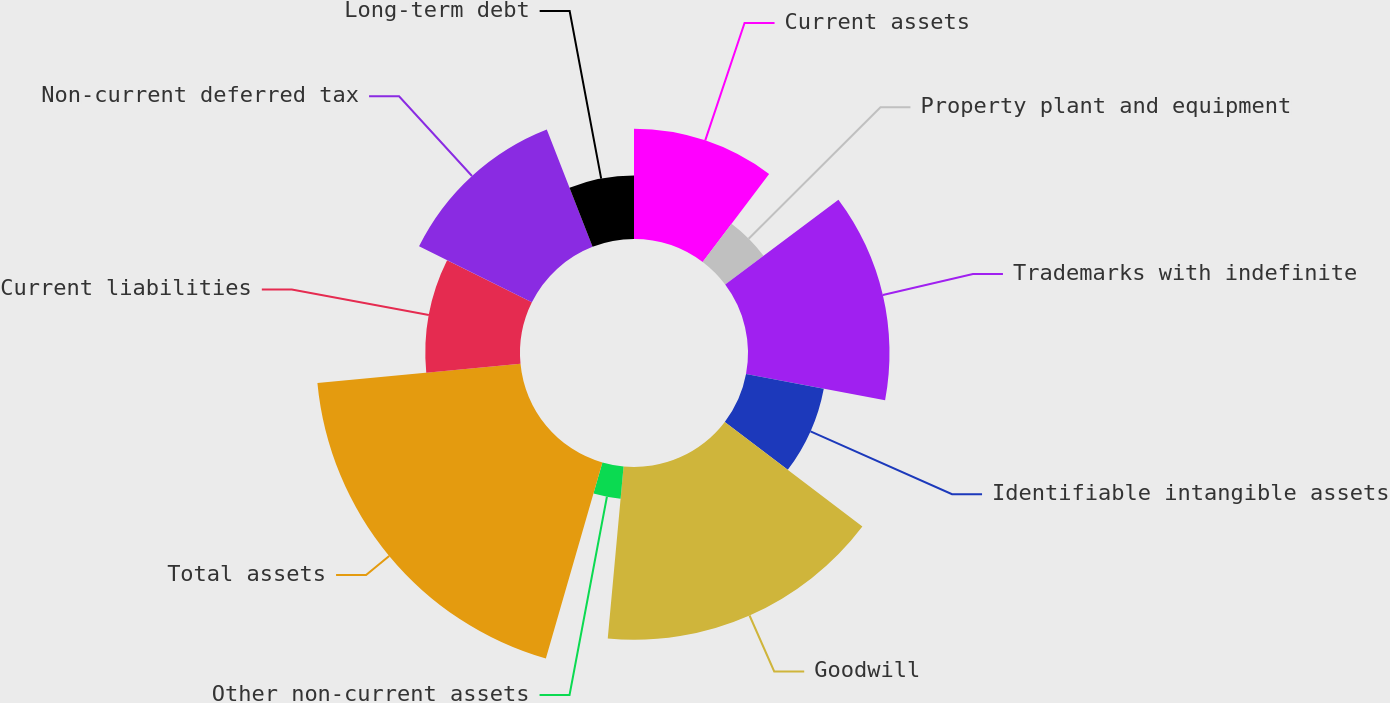Convert chart to OTSL. <chart><loc_0><loc_0><loc_500><loc_500><pie_chart><fcel>Current assets<fcel>Property plant and equipment<fcel>Trademarks with indefinite<fcel>Identifiable intangible assets<fcel>Goodwill<fcel>Other non-current assets<fcel>Total assets<fcel>Current liabilities<fcel>Non-current deferred tax<fcel>Long-term debt<nl><fcel>10.29%<fcel>4.47%<fcel>13.2%<fcel>7.38%<fcel>16.12%<fcel>3.01%<fcel>19.03%<fcel>8.83%<fcel>11.75%<fcel>5.92%<nl></chart> 